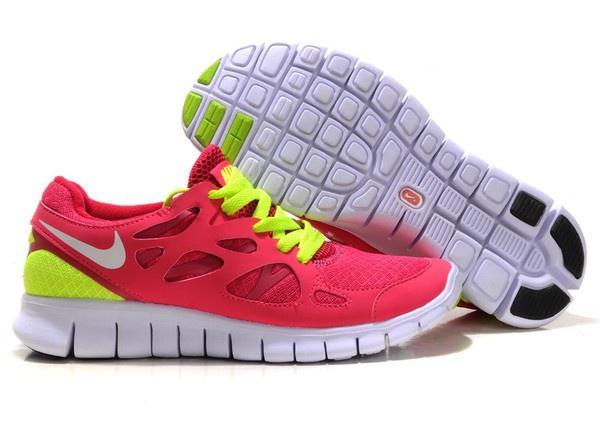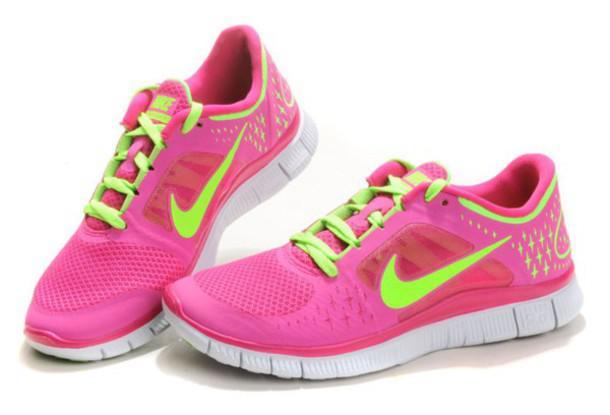The first image is the image on the left, the second image is the image on the right. Analyze the images presented: Is the assertion "Each image shows one laced-up shoe with a logo in profile, while a second shoe is angled behind it with the sole displayed." valid? Answer yes or no. No. The first image is the image on the left, the second image is the image on the right. For the images shown, is this caption "The bottom of a shoe sole is displayed facing the camera in each image." true? Answer yes or no. No. 